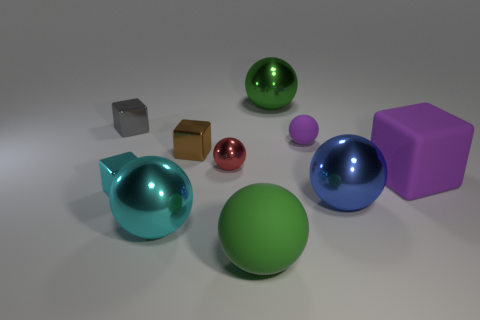Subtract all cyan spheres. How many spheres are left? 5 Subtract all cyan spheres. How many spheres are left? 5 Subtract all purple spheres. Subtract all yellow cylinders. How many spheres are left? 5 Subtract all balls. How many objects are left? 4 Subtract 0 yellow cubes. How many objects are left? 10 Subtract all large yellow rubber blocks. Subtract all small brown objects. How many objects are left? 9 Add 6 rubber cubes. How many rubber cubes are left? 7 Add 4 green shiny balls. How many green shiny balls exist? 5 